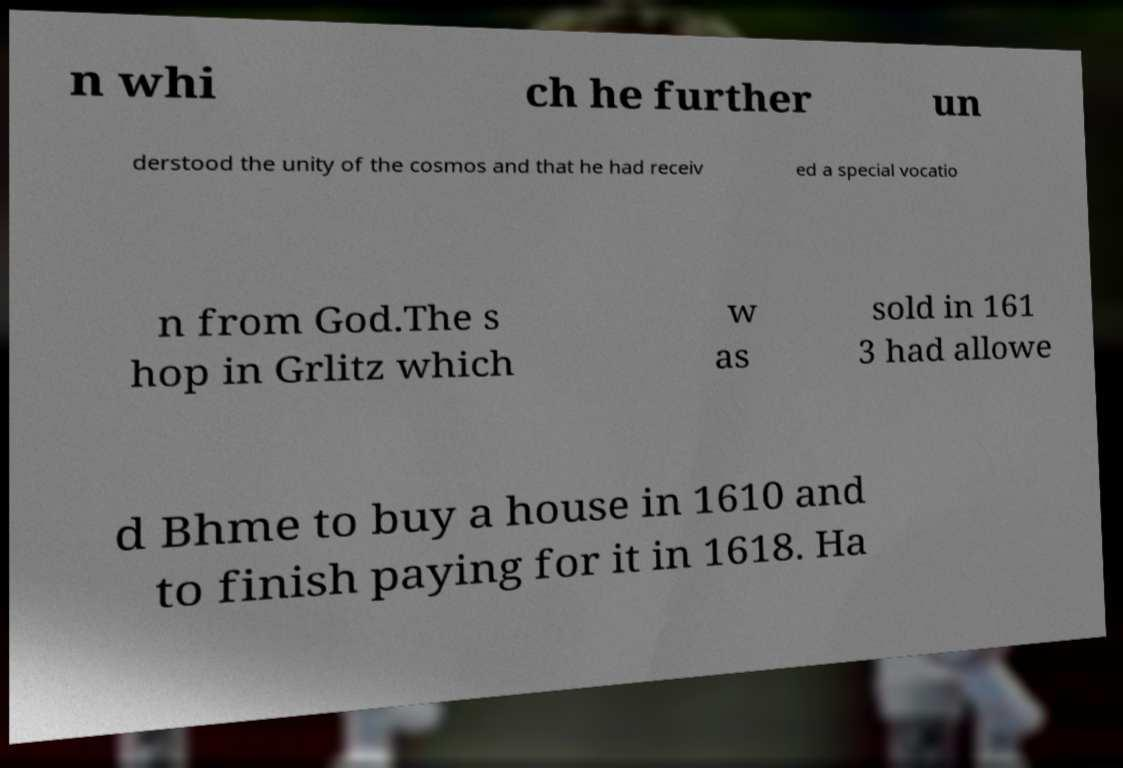Can you read and provide the text displayed in the image?This photo seems to have some interesting text. Can you extract and type it out for me? n whi ch he further un derstood the unity of the cosmos and that he had receiv ed a special vocatio n from God.The s hop in Grlitz which w as sold in 161 3 had allowe d Bhme to buy a house in 1610 and to finish paying for it in 1618. Ha 